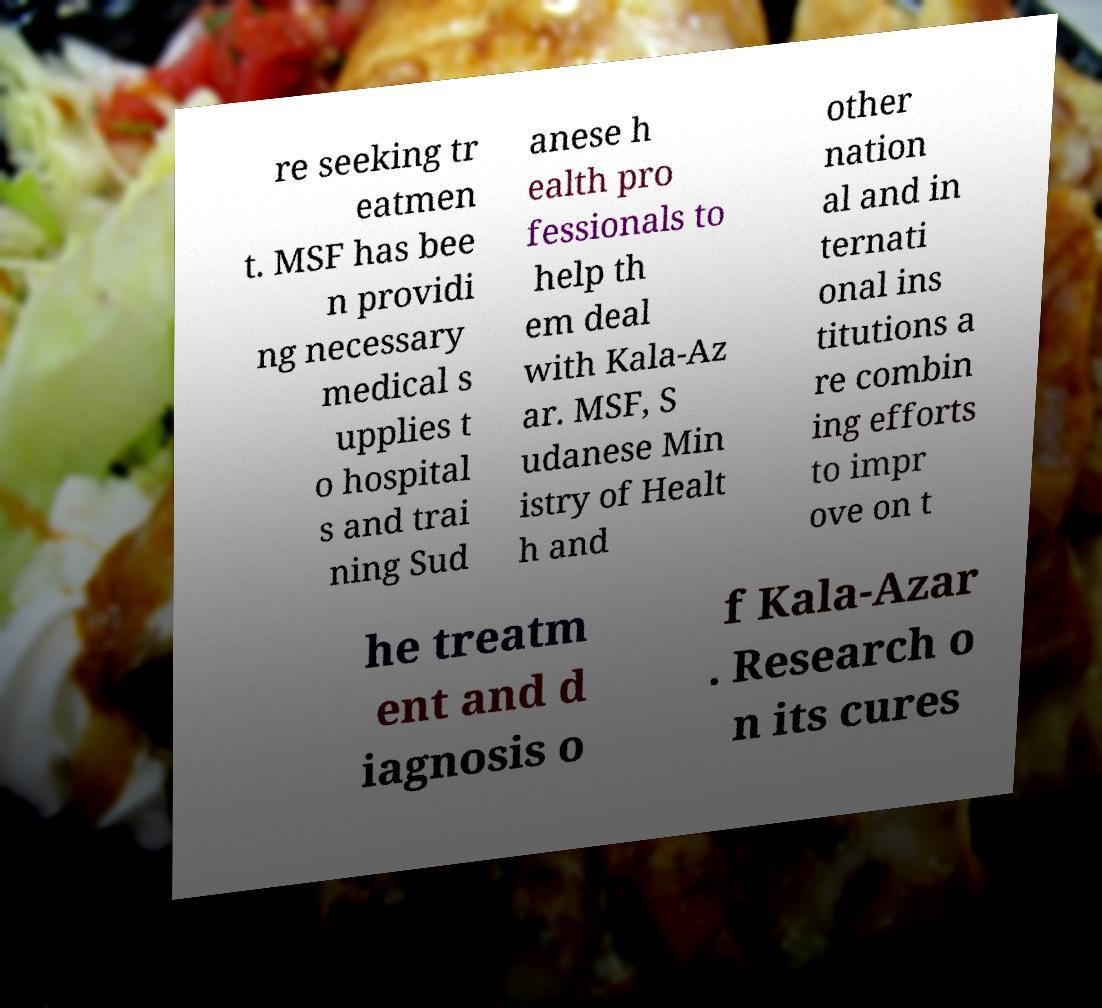Please read and relay the text visible in this image. What does it say? re seeking tr eatmen t. MSF has bee n providi ng necessary medical s upplies t o hospital s and trai ning Sud anese h ealth pro fessionals to help th em deal with Kala-Az ar. MSF, S udanese Min istry of Healt h and other nation al and in ternati onal ins titutions a re combin ing efforts to impr ove on t he treatm ent and d iagnosis o f Kala-Azar . Research o n its cures 